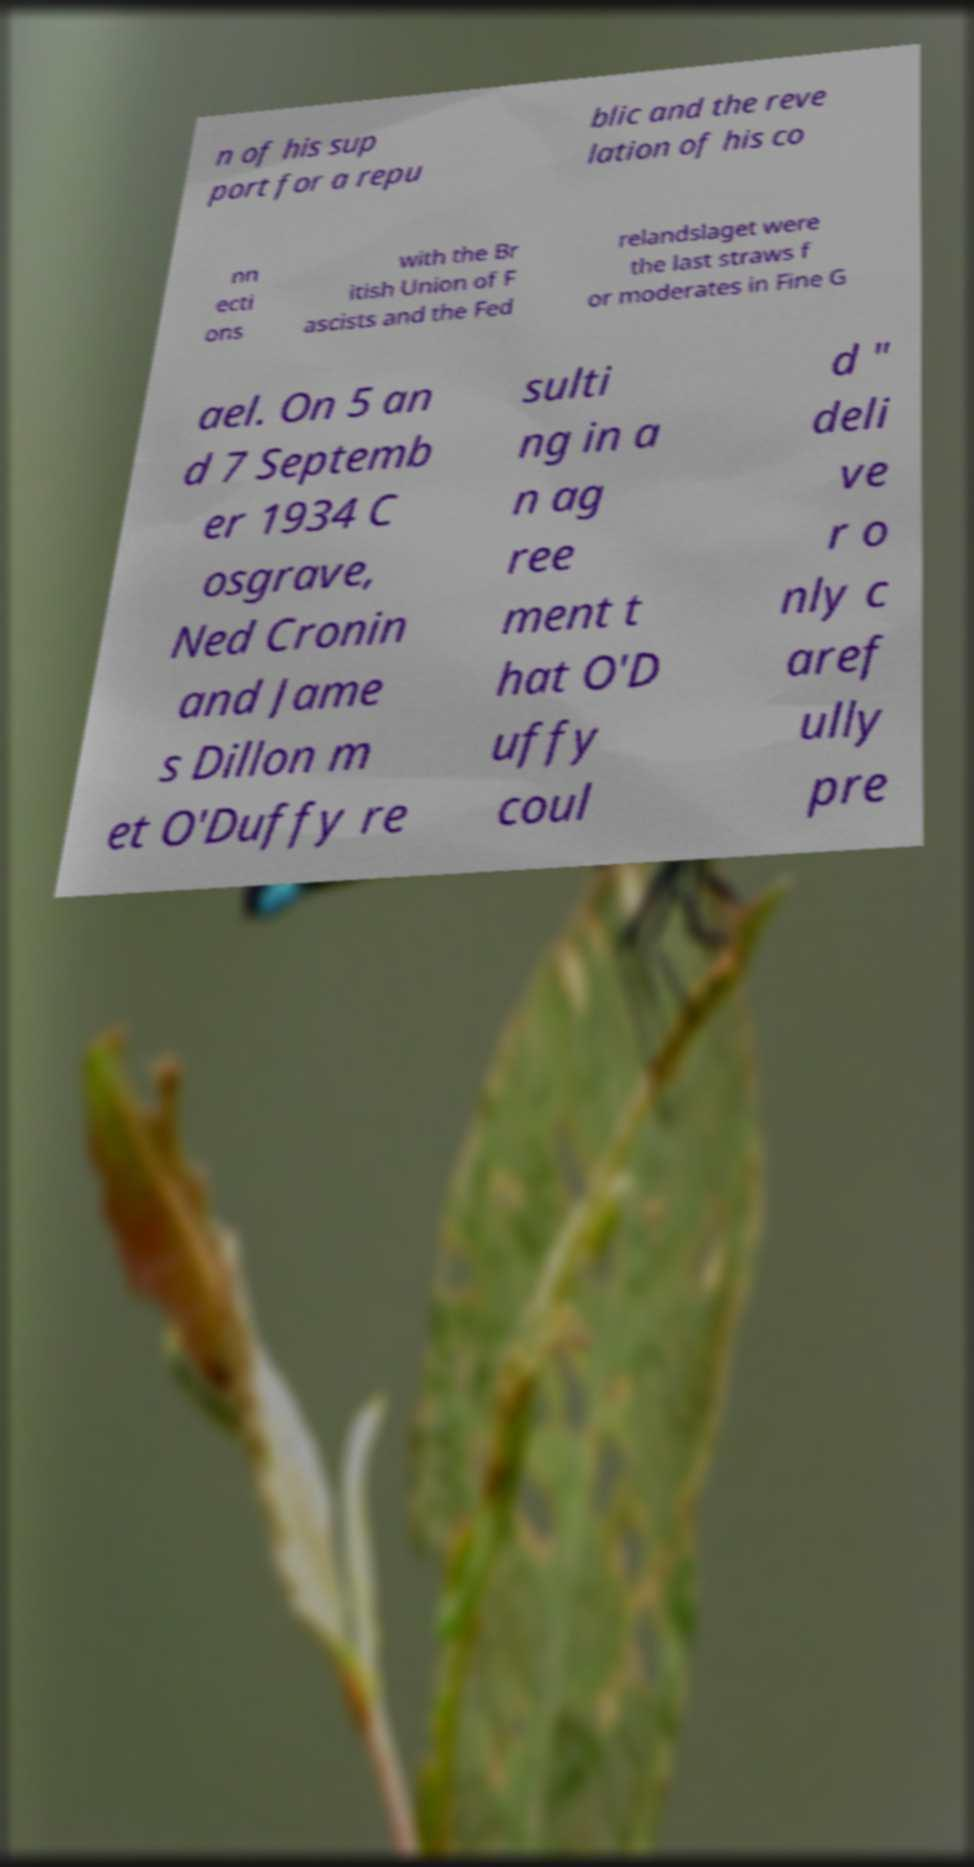Can you read and provide the text displayed in the image?This photo seems to have some interesting text. Can you extract and type it out for me? n of his sup port for a repu blic and the reve lation of his co nn ecti ons with the Br itish Union of F ascists and the Fed relandslaget were the last straws f or moderates in Fine G ael. On 5 an d 7 Septemb er 1934 C osgrave, Ned Cronin and Jame s Dillon m et O'Duffy re sulti ng in a n ag ree ment t hat O'D uffy coul d " deli ve r o nly c aref ully pre 